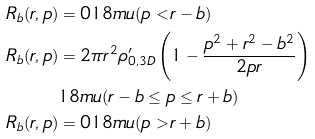<formula> <loc_0><loc_0><loc_500><loc_500>R _ { b } ( r , p ) & = 0 { 1 8 m u } ( p < r - b ) \\ R _ { b } ( r , p ) & = 2 \pi r ^ { 2 } \rho _ { 0 , 3 D } ^ { \prime } \left ( 1 - \frac { p ^ { 2 } + r ^ { 2 } - b ^ { 2 } } { 2 p r } \right ) \\ & { 1 8 m u } ( r - b \leq p \leq r + b ) \\ R _ { b } ( r , p ) & = 0 { 1 8 m u } ( p > r + b )</formula> 